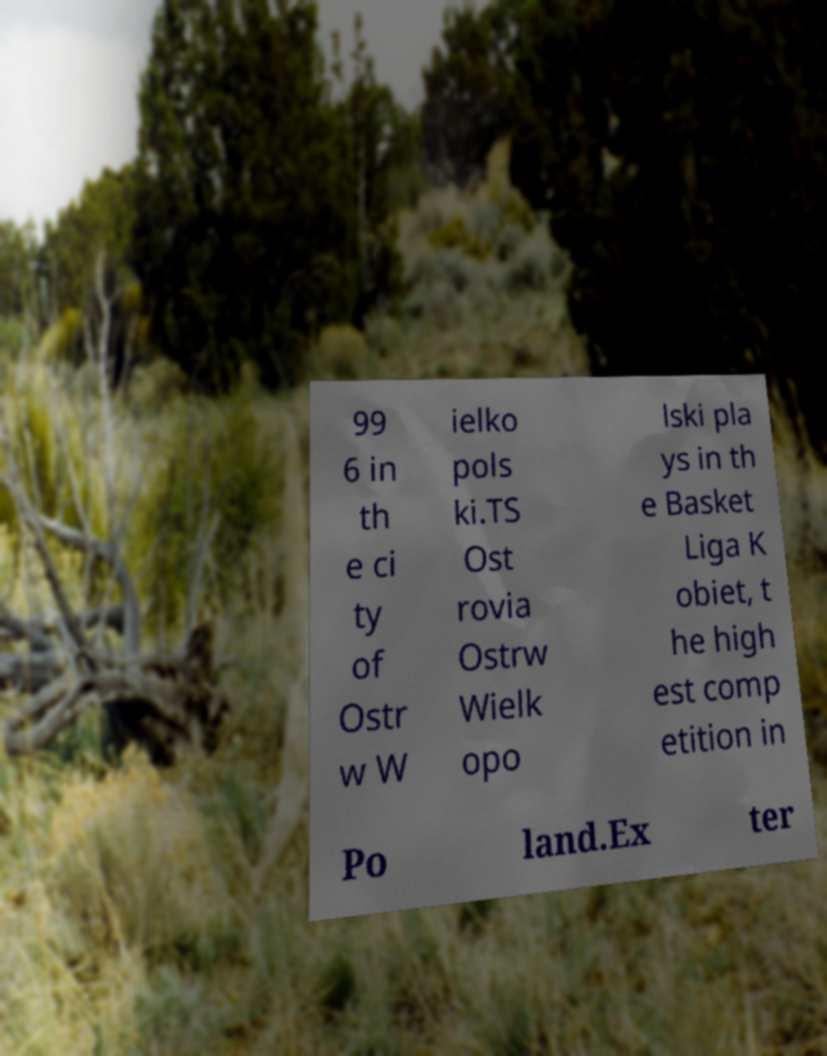There's text embedded in this image that I need extracted. Can you transcribe it verbatim? 99 6 in th e ci ty of Ostr w W ielko pols ki.TS Ost rovia Ostrw Wielk opo lski pla ys in th e Basket Liga K obiet, t he high est comp etition in Po land.Ex ter 